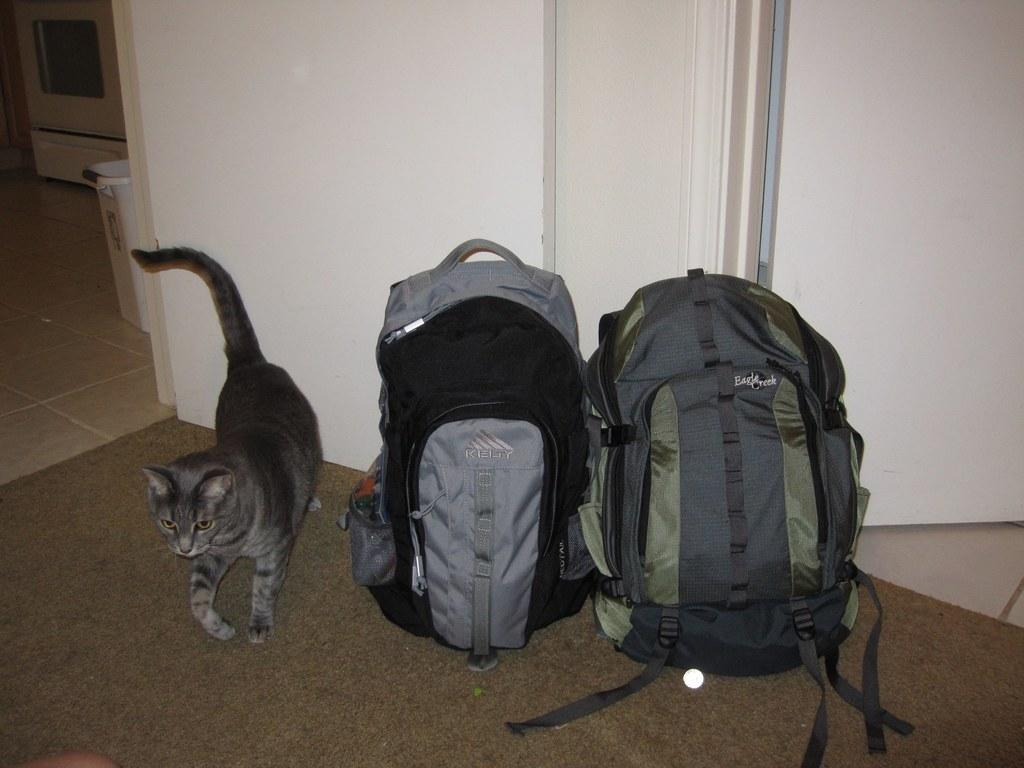What objects are on the floor in the image? There are two backpacks on the floor. What animal is to the left in the image? There is a cat to the left in the image. What can be seen in the background of the image? There is a wall and a door in the background of the image. What is at the bottom of the image? There is a floor mat at the bottom of the image. Where are the dinosaurs located in the image? There are no dinosaurs present in the image. What type of scarecrow can be seen in the image? There is no scarecrow present in the image. 